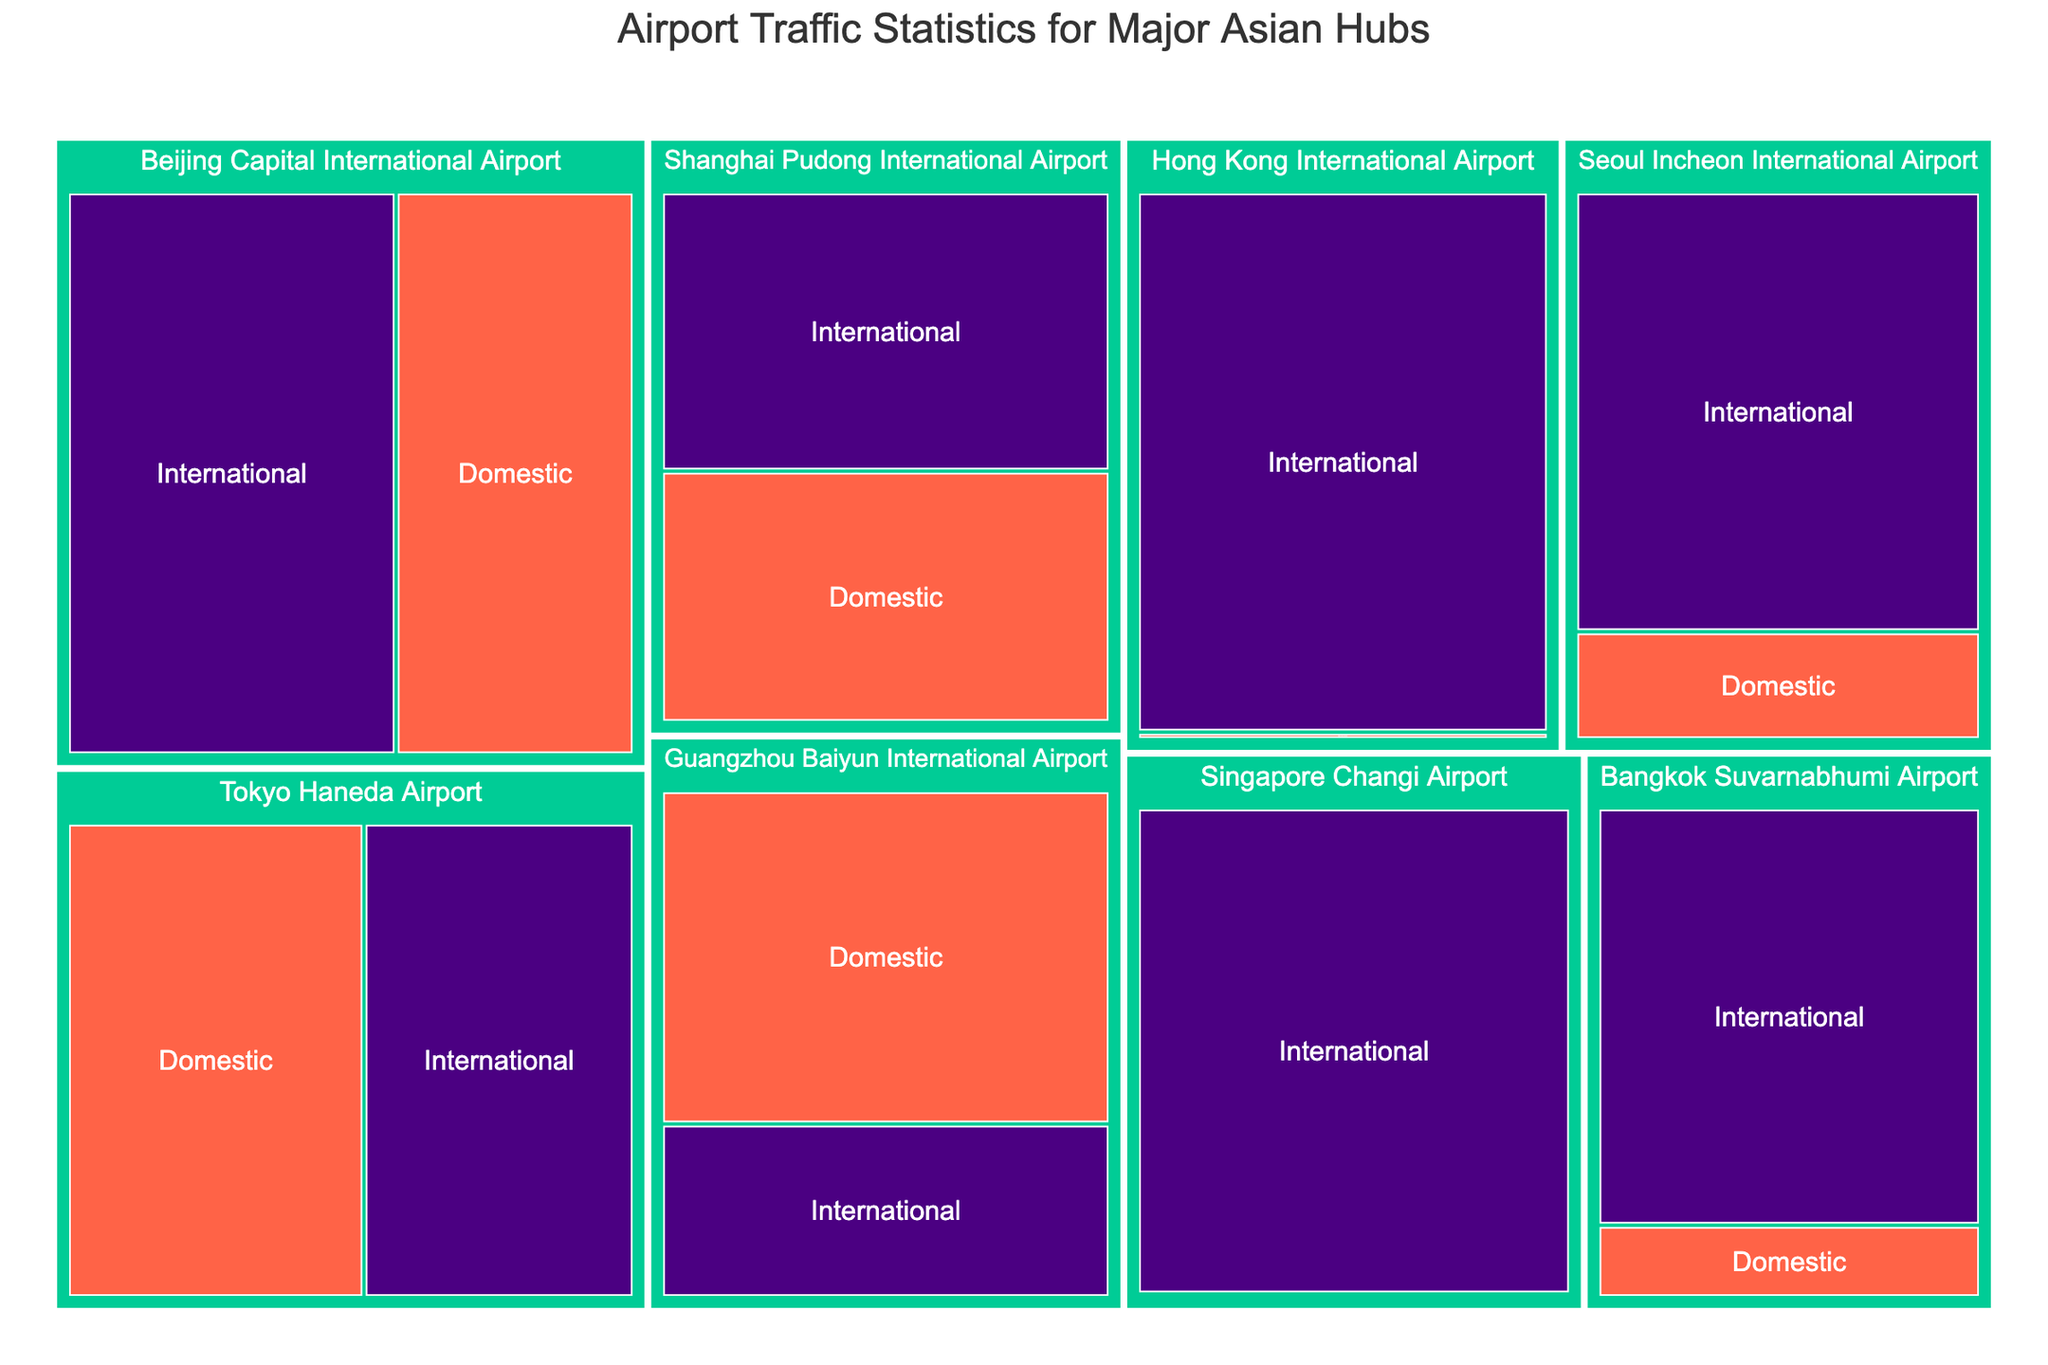1. What is the title of the figure? The title is displayed prominently, usually at the top of the figure. By reading it, we can understand the primary focus of the visualization.
Answer: Airport Traffic Statistics for Major Asian Hubs 2. Which airport has the highest international traffic? Locate the airport with the largest section under the "International" category in the treemap. The size of the block represents the traffic volume.
Answer: Hong Kong International Airport 3. What is the total traffic (domestic and international) for Beijing Capital International Airport? Sum the domestic and international traffic figures for Beijing Capital International Airport, which are displayed in two separate sections of the treemap.
Answer: 100,000,000 4. How does the domestic traffic of Tokyo Haneda Airport compare to Seoul Incheon International Airport? Compare the sizes of the blocks representing domestic traffic for both Tokyo Haneda Airport and Seoul Incheon International Airport. The traffic numbers should be directly readable.
Answer: Tokyo Haneda has more domestic traffic 5. Which airport has the smallest domestic traffic? Find the smallest block within the "Domestic" category in the treemap. The traffic number corresponds to the lowest value.
Answer: Singapore Changi Airport 6. What is the difference in international traffic between Bangkok Suvarnabhumi Airport and Shanghai Pudong International Airport? Subtract the international traffic figure of Shanghai Pudong from that of Bangkok Suvarnabhumi. Refer to the international category blocks for both airports.
Answer: 12,000,000 7. How many airports have both domestic and international traffic? Count the number of airports that have both a domestic and an international category block shown in the treemap.
Answer: 6 8. Which airport has the largest discrepancy between domestic and international traffic? Calculate the difference between domestic and international traffic for each airport. The airport with the biggest absolute difference is the answer.
Answer: Hong Kong International Airport 9. What is the average international traffic for all the airports listed? Sum up the international traffic for all airports and divide by the number of airports (7).
Answer: 49,285,714 10. Which airport’s domestic traffic is closest to the international traffic of Guangzhou Baiyun International Airport? Compare the domestic traffic of each airport with the international traffic of Guangzhou Baiyun International (25,000,000) and find the closest match.
Answer: Tokyo Haneda Airport 